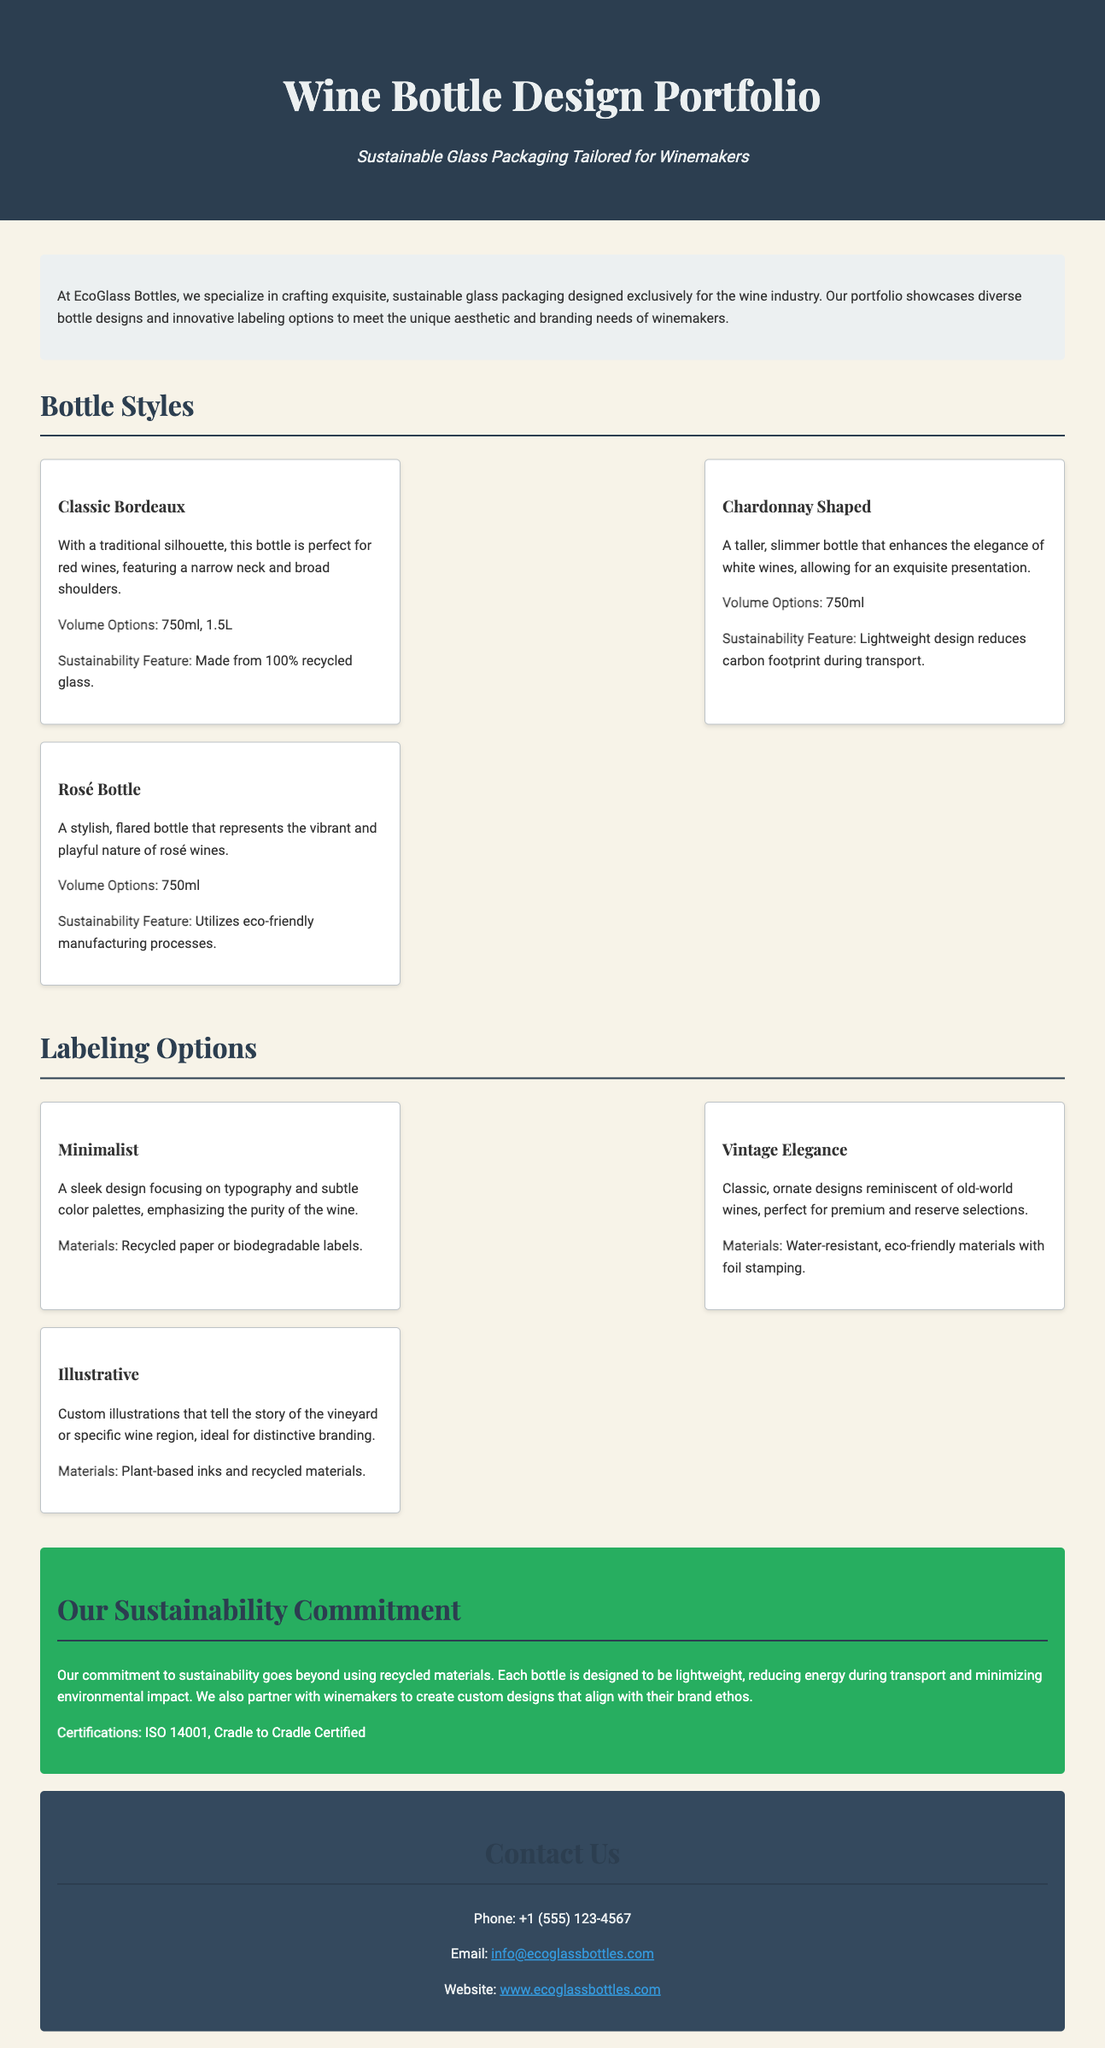what is the title of the portfolio? The title of the portfolio is prominently displayed at the top of the document.
Answer: Wine Bottle Design Portfolio how many bottle styles are showcased? The section on bottle styles lists three distinct designs.
Answer: 3 which bottle is described as perfect for red wines? The document specifies the intended use of various bottles, highlighting one for red wines.
Answer: Classic Bordeaux what material is used for the Minimalist labeling option? The document contains specific materials listed under each labeling option, including one for the Minimalist design.
Answer: Recycled paper or biodegradable labels what sustainability certification is mentioned? The sustainability section lists certifications that the company adheres to for its eco-friendly practices.
Answer: ISO 14001 which two features are noted for the Chardonnay Shaped bottle? The document describes key features of the Chardonnay Shaped bottle in relation to sustainability and design.
Answer: Lightweight design reduces carbon footprint what labeling option is ideal for distinctive branding? The document summarizes the purpose of each labeling style, linking one to branding.
Answer: Illustrative how are the Vintage Elegance labels characterized? The description of this labeling option outlines its stylistic features and materials.
Answer: Classic, ornate designs what is one way the portfolio emphasizes sustainability? The sustainability commitment section describes efforts beyond just materials used.
Answer: Lightweight design reduces energy during transport 